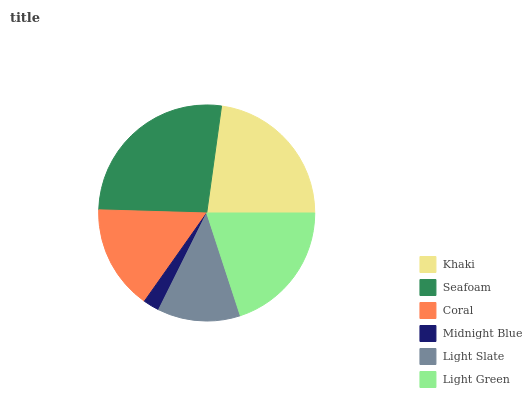Is Midnight Blue the minimum?
Answer yes or no. Yes. Is Seafoam the maximum?
Answer yes or no. Yes. Is Coral the minimum?
Answer yes or no. No. Is Coral the maximum?
Answer yes or no. No. Is Seafoam greater than Coral?
Answer yes or no. Yes. Is Coral less than Seafoam?
Answer yes or no. Yes. Is Coral greater than Seafoam?
Answer yes or no. No. Is Seafoam less than Coral?
Answer yes or no. No. Is Light Green the high median?
Answer yes or no. Yes. Is Coral the low median?
Answer yes or no. Yes. Is Light Slate the high median?
Answer yes or no. No. Is Light Slate the low median?
Answer yes or no. No. 